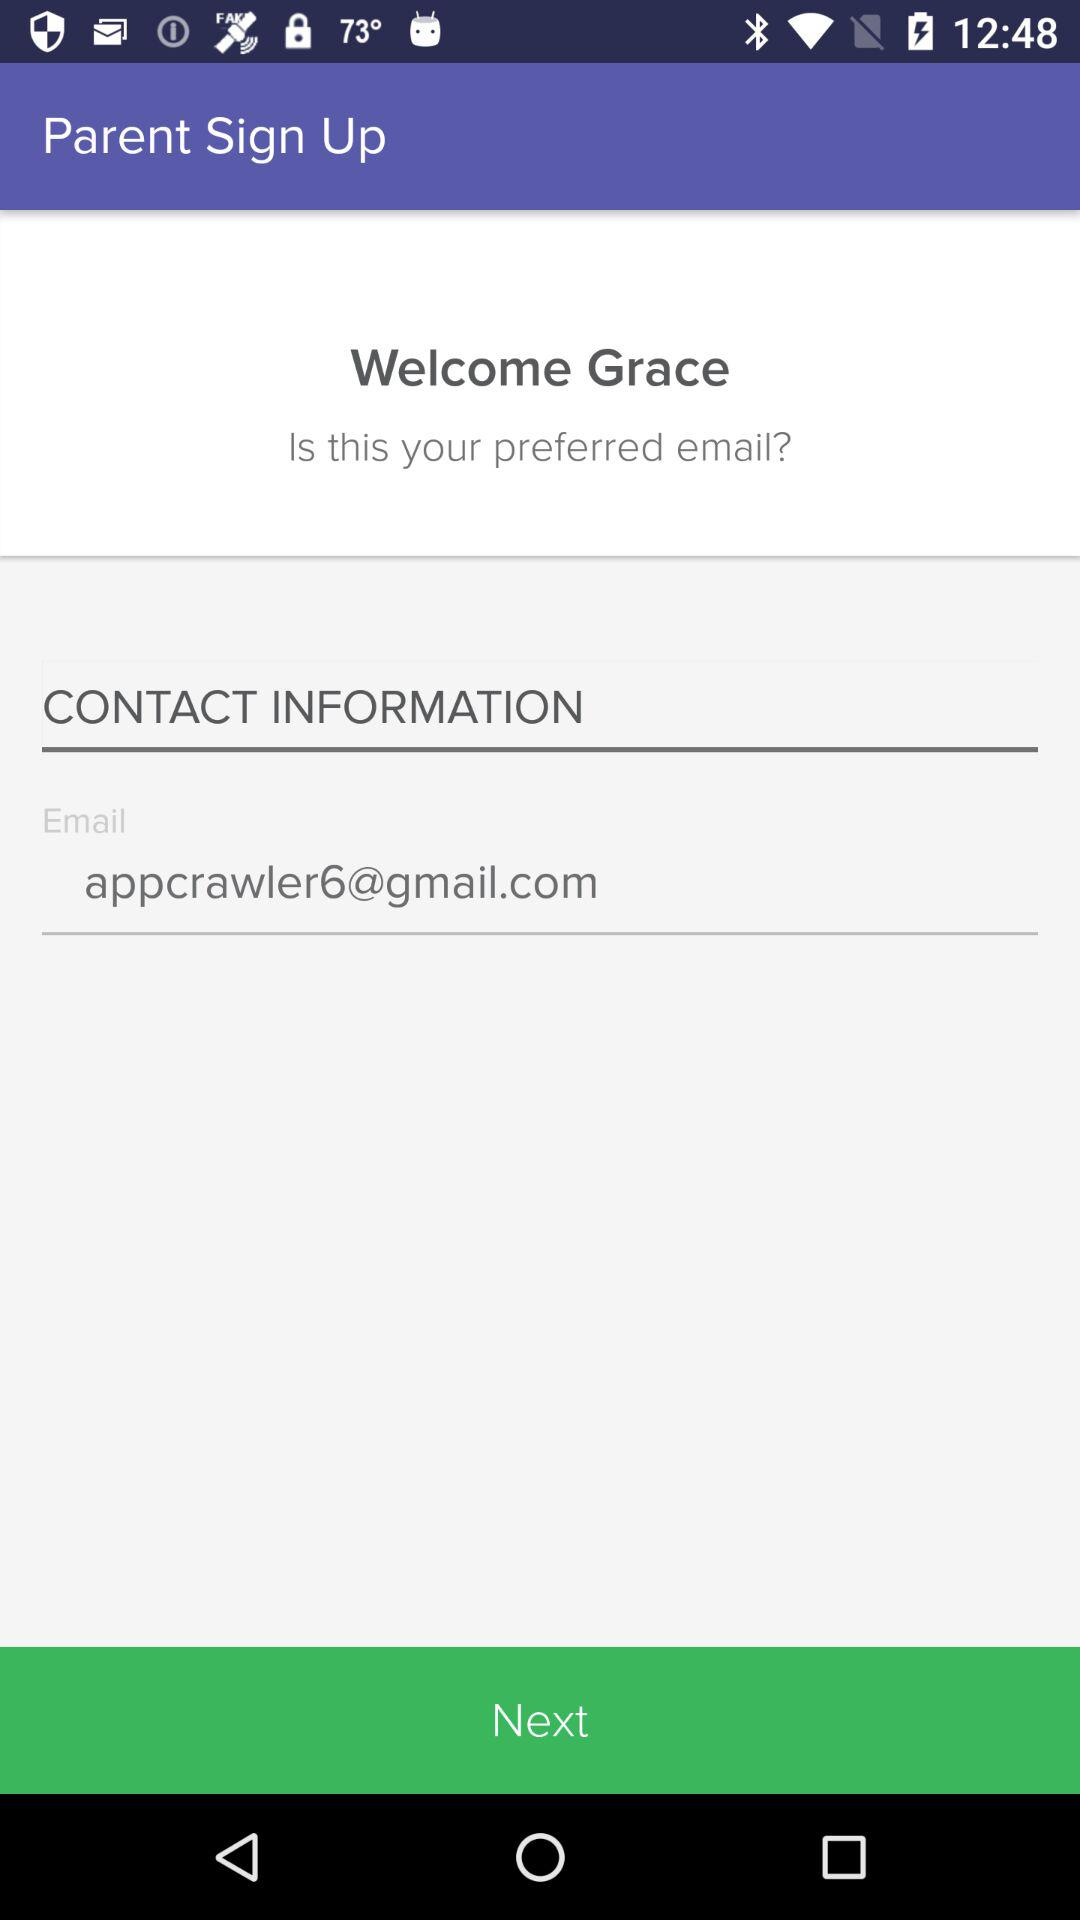What is the user name? The user name is Grace. 